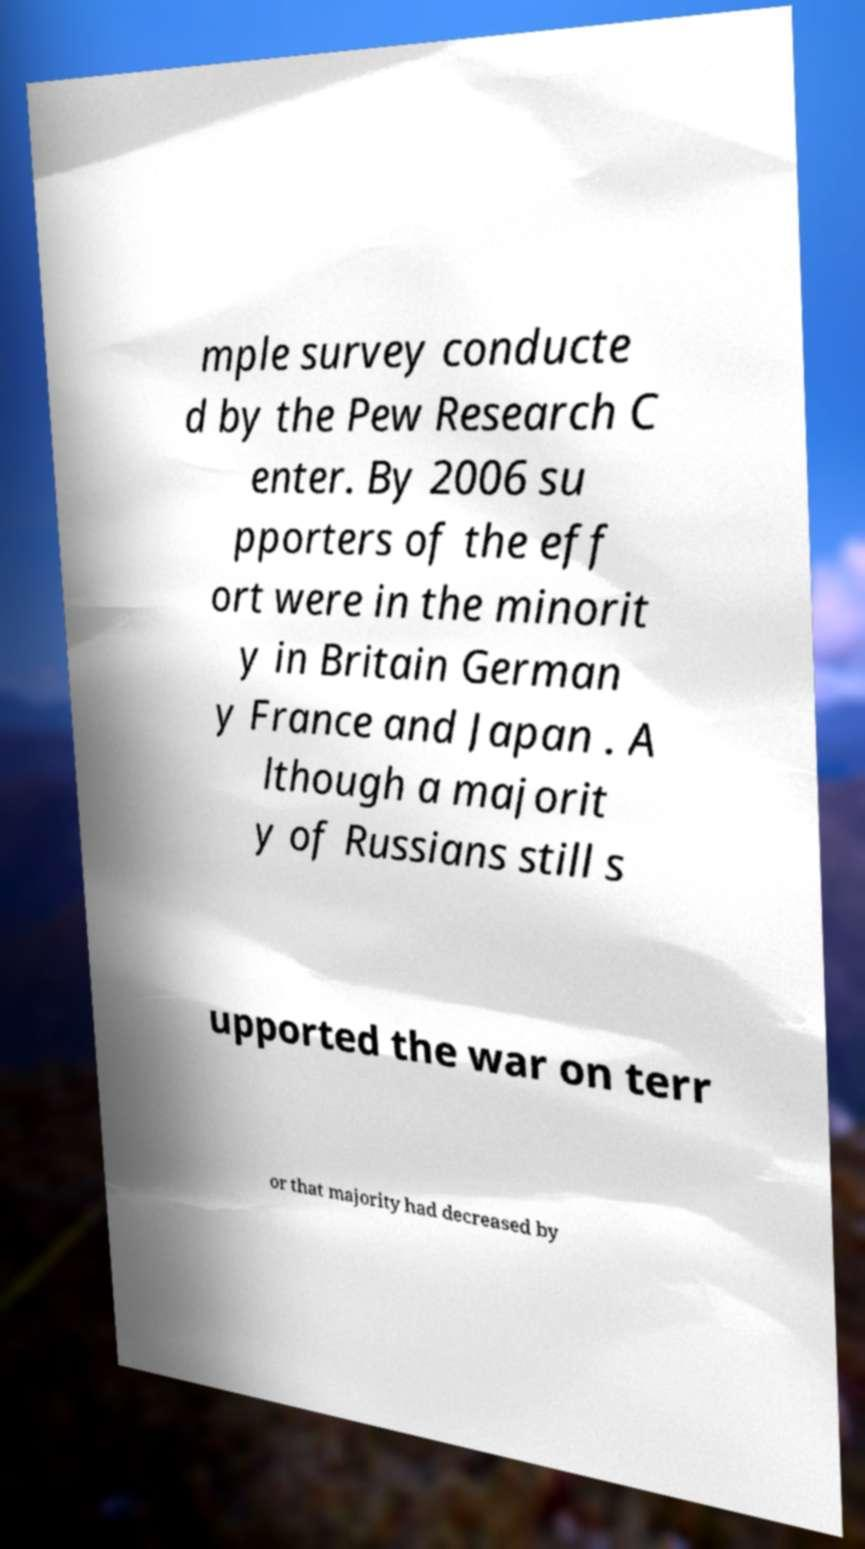There's text embedded in this image that I need extracted. Can you transcribe it verbatim? mple survey conducte d by the Pew Research C enter. By 2006 su pporters of the eff ort were in the minorit y in Britain German y France and Japan . A lthough a majorit y of Russians still s upported the war on terr or that majority had decreased by 